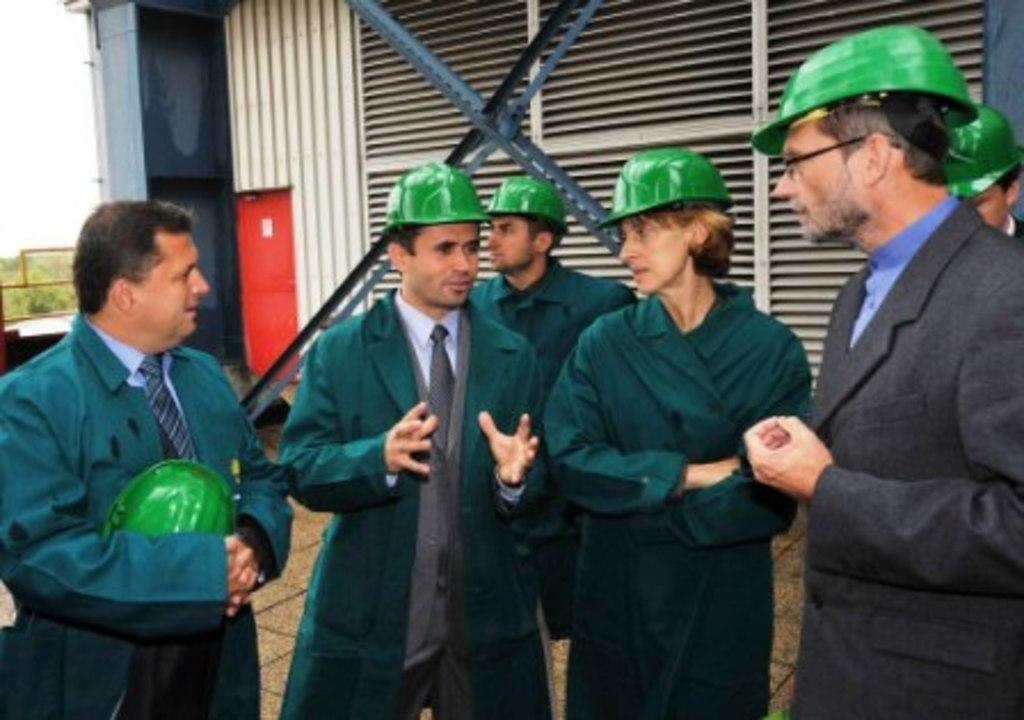How many people are present in the image? There are six people in the image. What are the people wearing on their heads? The people are wearing green helmets. What can be seen in the background of the image? There is a building and trees in the background of the image. What type of car is visible in the fog in the image? There is no car or fog present in the image. 